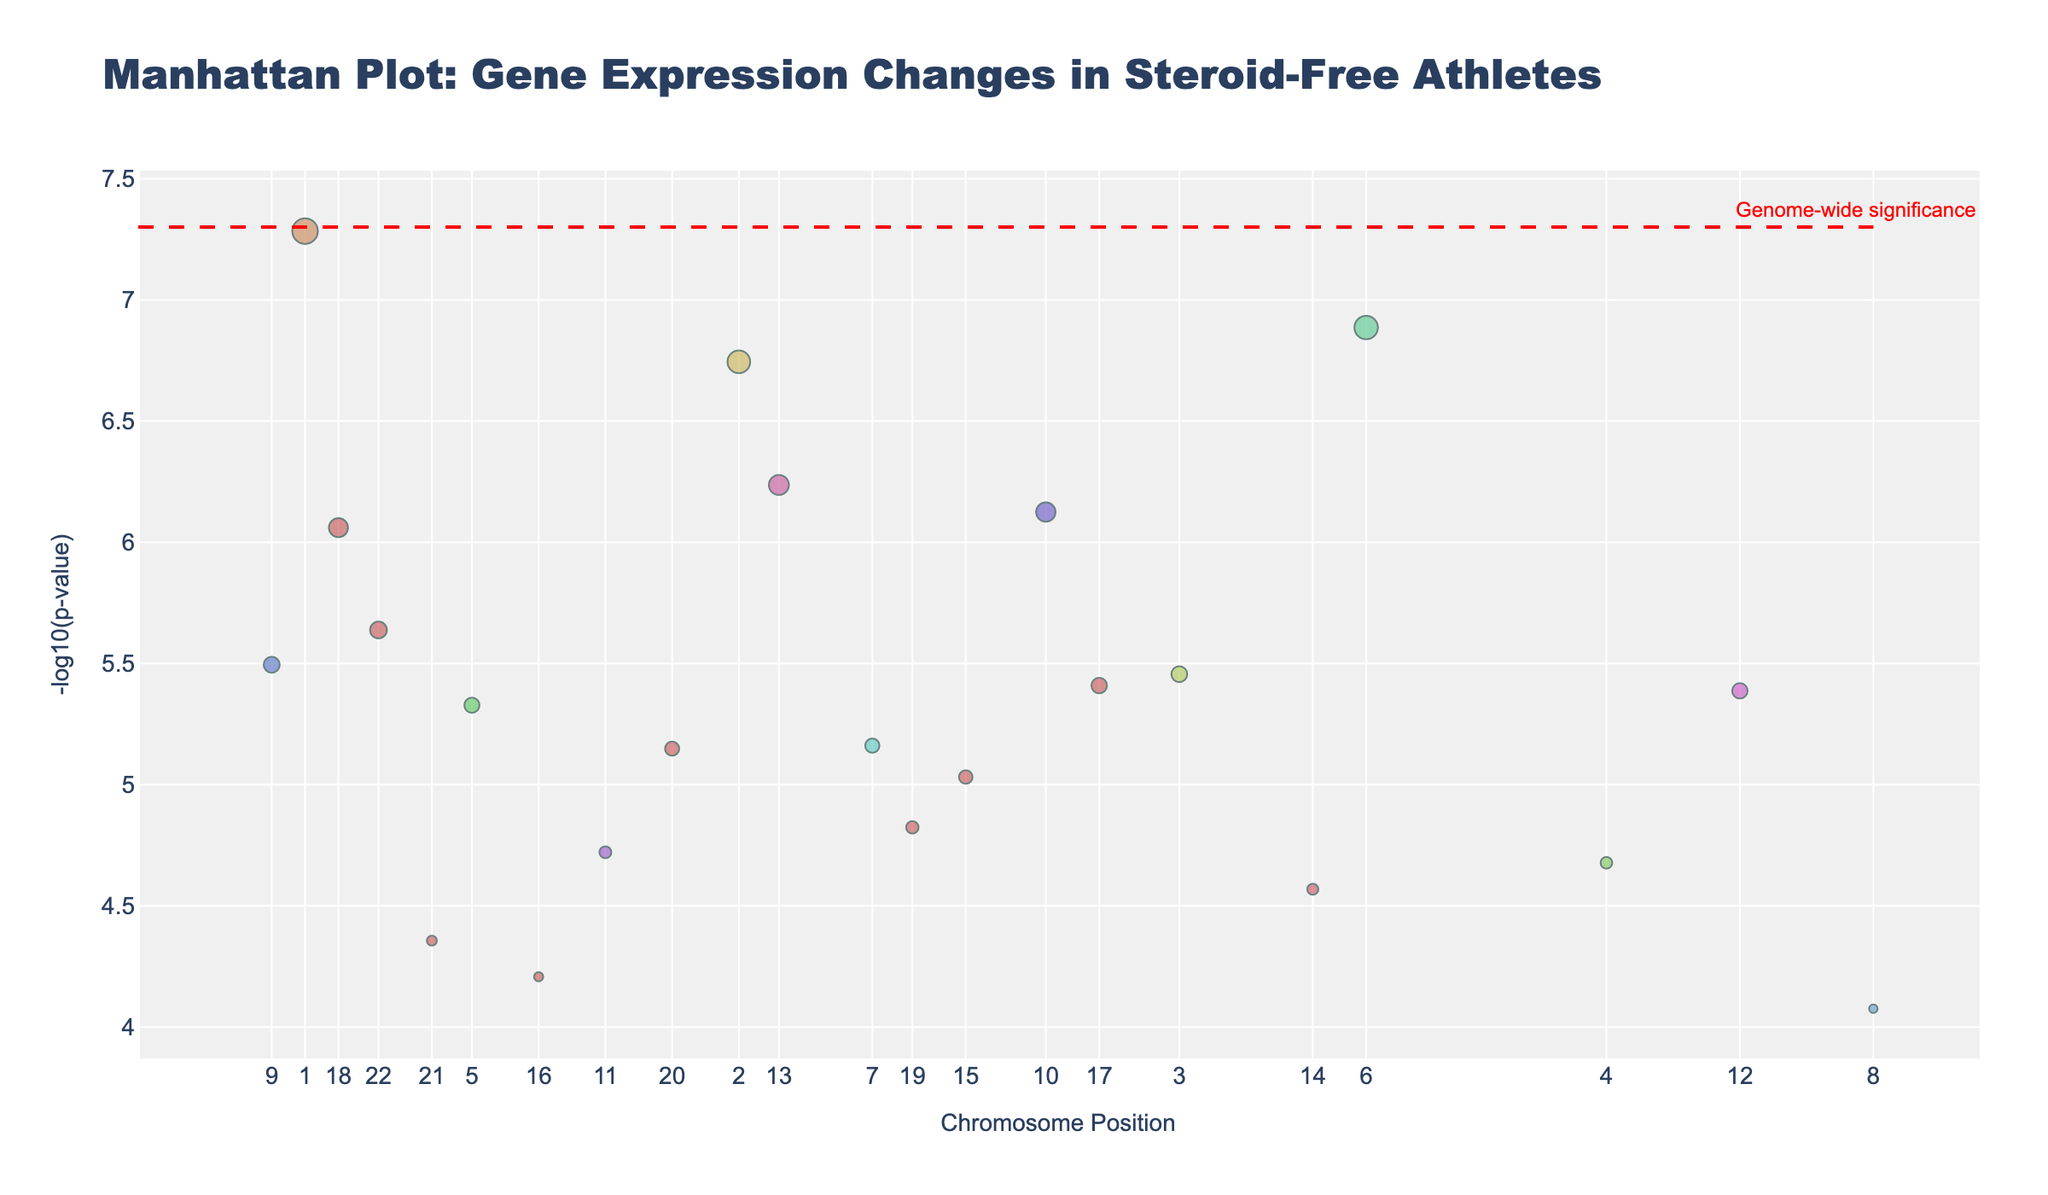What is the title of the plot? The title is displayed at the top of the plot. It reads, "Manhattan Plot: Gene Expression Changes in Steroid-Free Athletes."
Answer: Manhattan Plot: Gene Expression Changes in Steroid-Free Athletes Which gene has the lowest p-value? The gene with the lowest p-value will have the highest -log10(p-value) on the y-axis. From the plot, ACTN3 has the highest point.
Answer: ACTN3 How many chromosomes are presented in the plot? The x-axis has tick marks and labels for each chromosome included in the plot. Counting them gives the number, which are 22 in total.
Answer: 22 Which gene on chromosome 6 has the lowest p-value? On chromosome 6, observe the y-axis (height) of the points; the highest point represents the lowest p-value. The gene is CKM.
Answer: CKM Is any gene above the genome-wide significance line? There is a red dashed line which represents the genome-wide significance threshold. Any gene point above this line satisfies this criterion. The genes ACTN3 and IL6 are above this line.
Answer: Yes Which gene's expression changes show the highest significance on chromosome 12? Locate the points for chromosome 12. Compare their heights (y-values representing -log10(p-values)); the highest one corresponds to the most significant gene. For chromosome 12, IGF1 is the highest.
Answer: IGF1 What is the average -log10(p-value) for genes on chromosome 10 and chromosome 12? First, identify the points on chromosomes 10 and 12, extract their -log10(p-values), add them, and divide by the number of genes. Chromosome 10 has ADRB2 with -log10(p) = 6.13. Chromosome 12 has IGF1 with -log10(p) = 5.39. Average = (6.13 + 5.39) / 2 = 5.76.
Answer: 5.76 Which chromosome has the gene expression at position 15000000? Locate the x-axis label for position 15000000 and identify the corresponding chromosome from the axis labels. This position lies on chromosome 18.
Answer: Chromosome 18 Compare the significance of gene CREB1 and gene BDKRB2. Which is more significant? Observe the height of the points for CREB1 and BDKRB2 representing their -log10(p-values). Higher points indicate more significance. CREB1 is higher than BDKRB2.
Answer: CREB1 is more significant What is the significance cut-off used in the plot? There is a red dashed line indicated by an annotation which specifies the genome-wide significance threshold. The y-value of this line represents the cut-off, which is -log10(5e-8).
Answer: -log10(5e-8) 